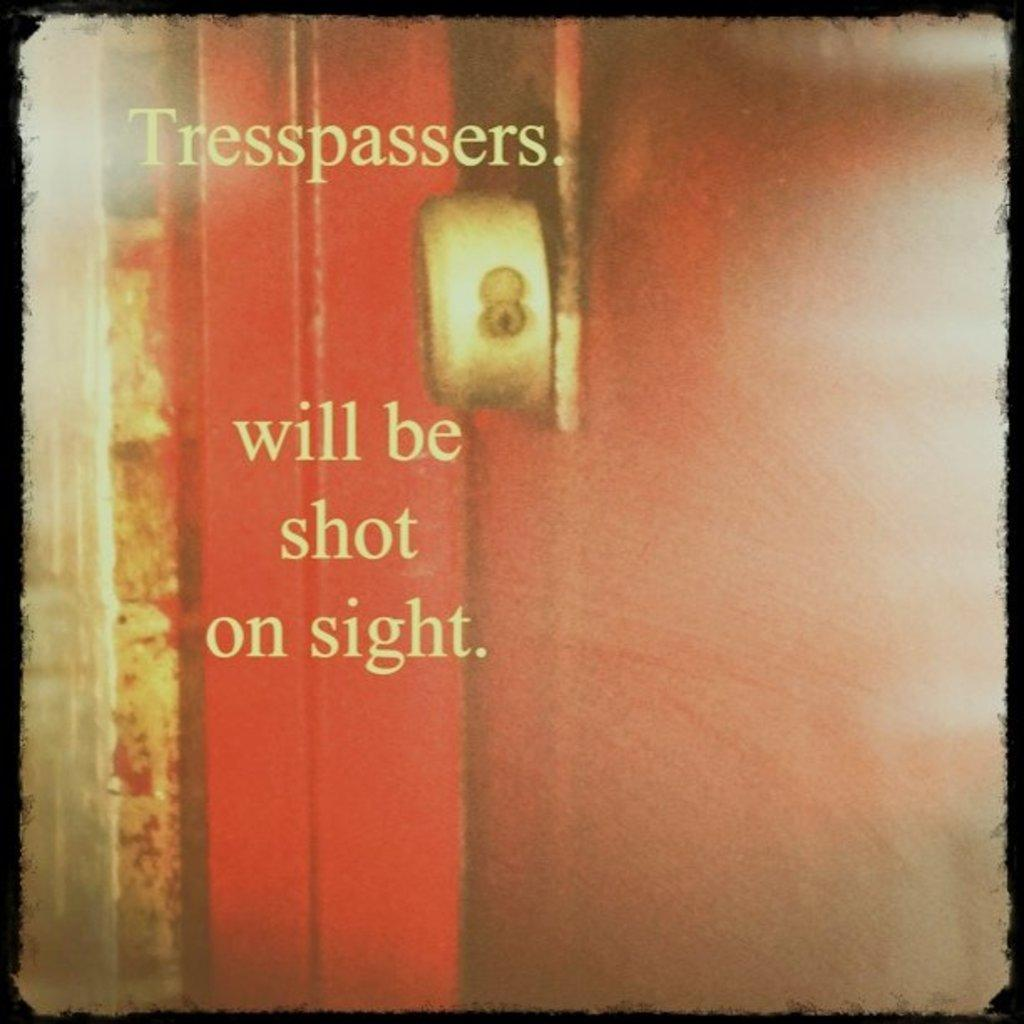<image>
Create a compact narrative representing the image presented. The paper warned that trespassers will be shot on sight. 